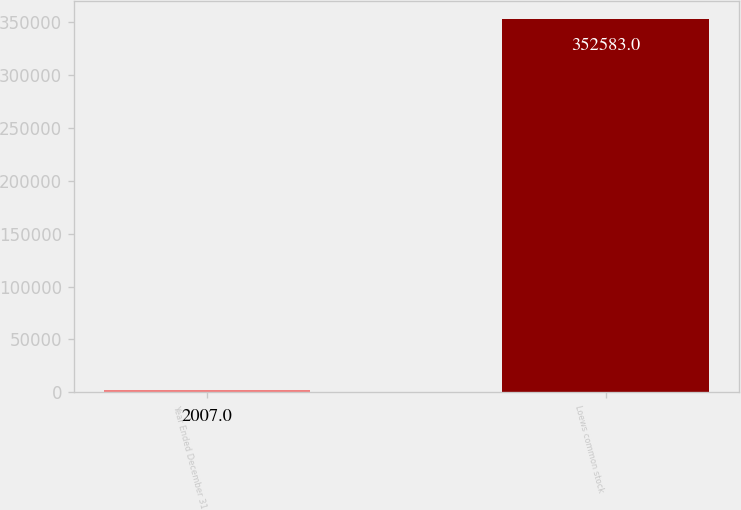Convert chart to OTSL. <chart><loc_0><loc_0><loc_500><loc_500><bar_chart><fcel>Year Ended December 31<fcel>Loews common stock<nl><fcel>2007<fcel>352583<nl></chart> 